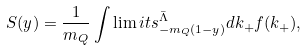Convert formula to latex. <formula><loc_0><loc_0><loc_500><loc_500>S ( y ) = \frac { 1 } { m _ { Q } } \int \lim i t s _ { - m _ { Q } ( 1 - y ) } ^ { \bar { \Lambda } } d k _ { + } f ( k _ { + } ) ,</formula> 